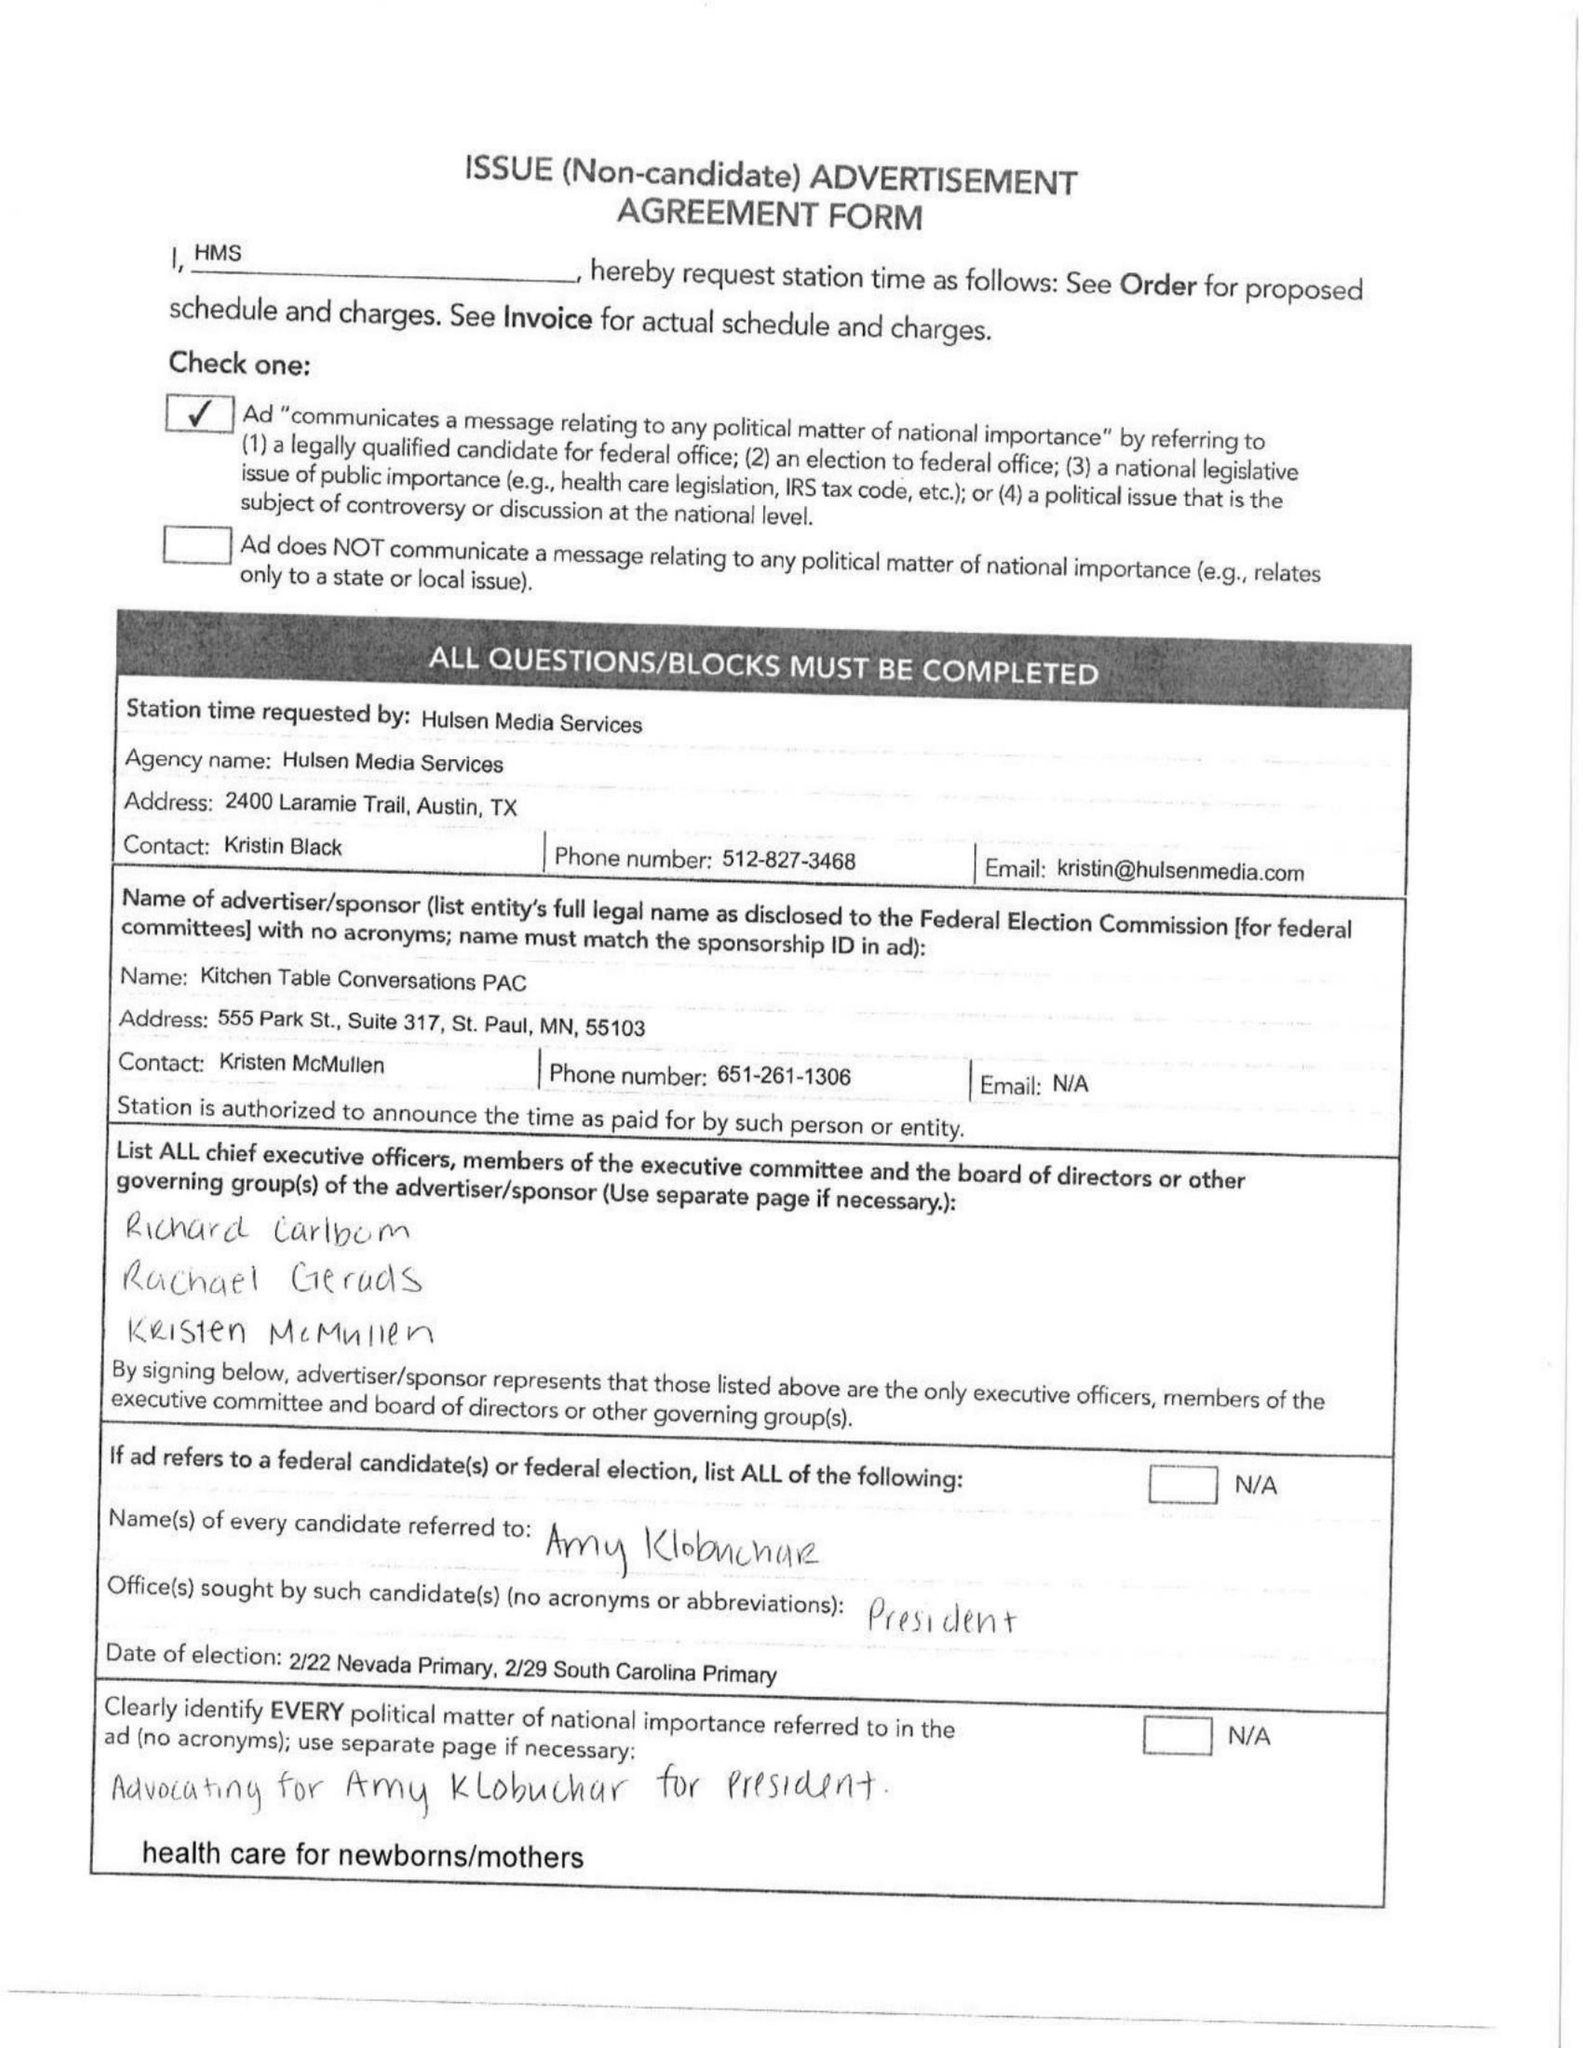What is the value for the contract_num?
Answer the question using a single word or phrase. 1350830 